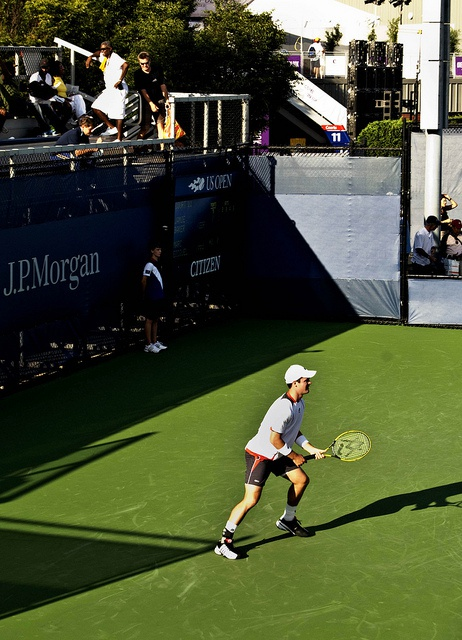Describe the objects in this image and their specific colors. I can see people in black, lightgray, olive, and gray tones, people in black, white, maroon, and darkgray tones, people in black, maroon, khaki, and lightyellow tones, people in black, gray, darkgray, and white tones, and people in black, darkgray, and gray tones in this image. 